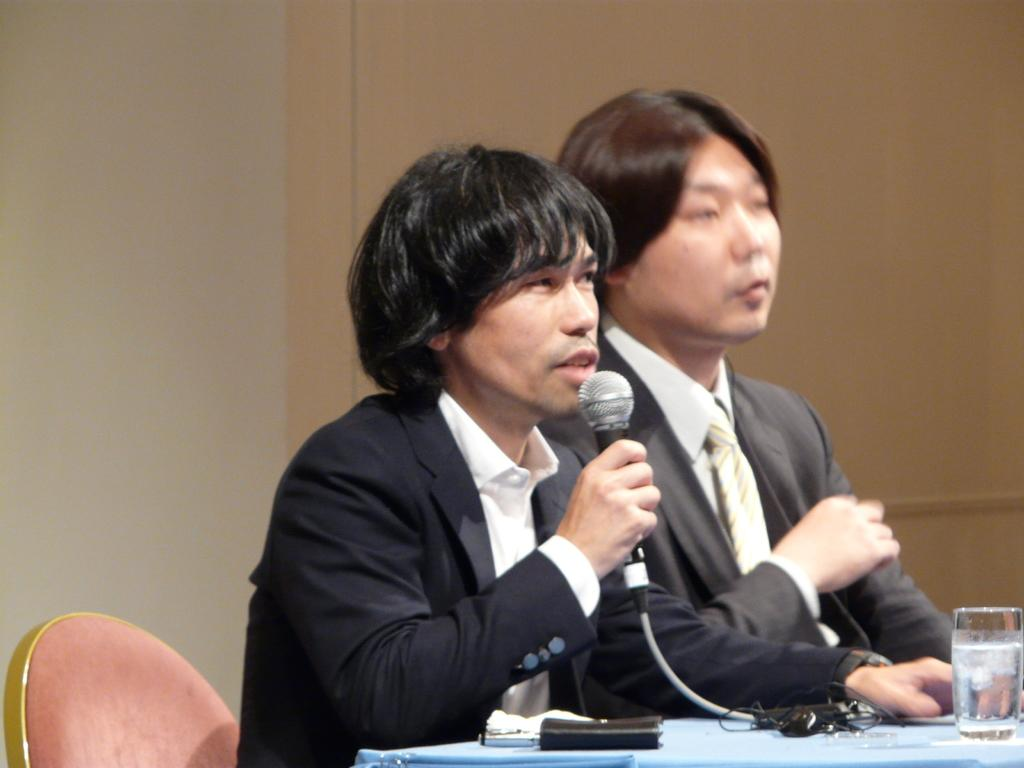How many people are sitting in the image? There are two people sitting on chairs in the image. What object is present that might be used for amplifying sound? There is a microphone in the image. What can be seen on the table in the image? There is a water glass on a table in the image. Reasoning: Let's let's think step by step in order to produce the conversation. We start by identifying the main subjects in the image, which are the two people sitting on chairs. Then, we describe the objects that are present in the image, such as the microphone and the water glass on the table. Each question is designed to elicit a specific detail about the image that is known from the provided facts. Absurd Question/Answer: What type of whip is being used by one of the people in the image? There is no whip present in the image; it features two people sitting on chairs and a microphone. What type of whip is being used by one of the people in the image? There is no whip present in the image; it features two people sitting on chairs and a microphone. 